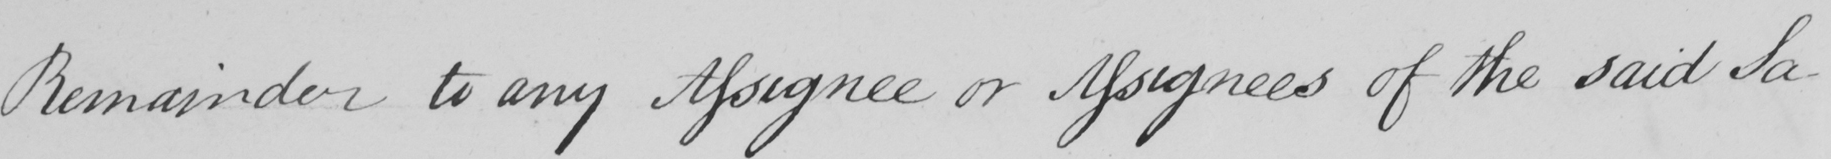Please transcribe the handwritten text in this image. Remainder to any Assignee or Assignees of the said Sa- 